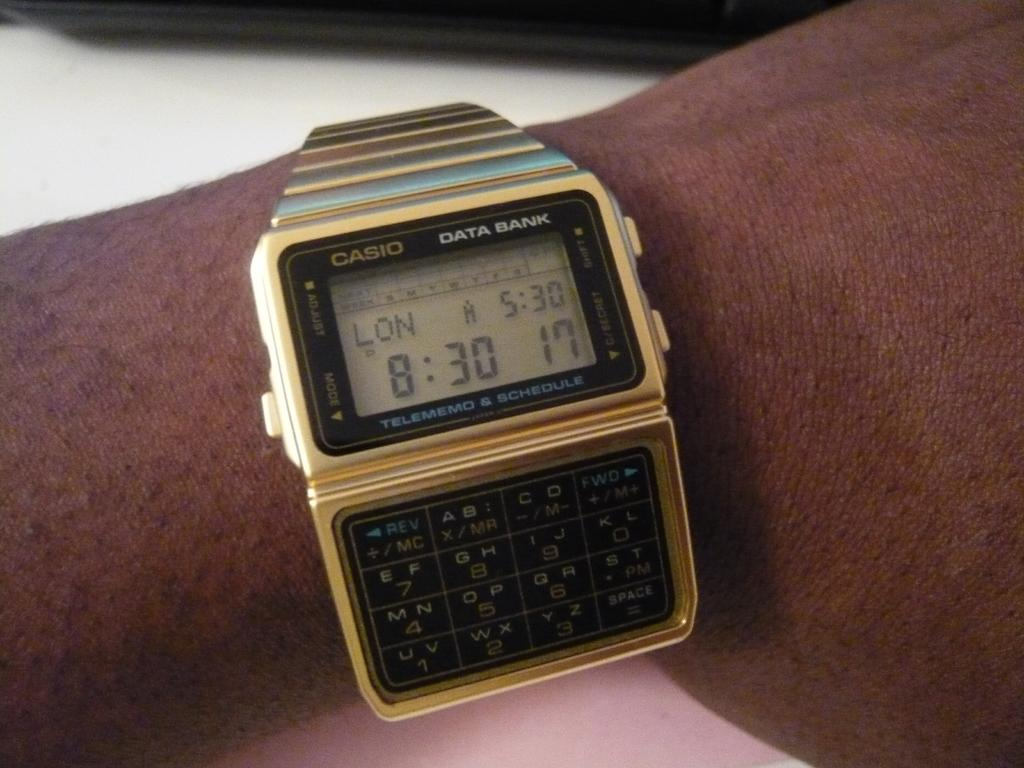Who or what is the main subject of the image? There is a person in the image. What accessory is the person wearing? The person is wearing a watch. What piece of furniture is visible at the bottom of the image? There is a table at the bottom of the image. What type of fruit is being cut on the table in the image? There is no fruit visible in the image, and no indication that any fruit is being cut. 